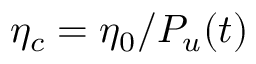<formula> <loc_0><loc_0><loc_500><loc_500>\eta _ { c } = \eta _ { 0 } / P _ { u } ( t )</formula> 